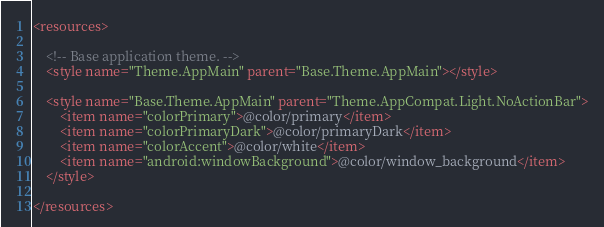Convert code to text. <code><loc_0><loc_0><loc_500><loc_500><_XML_><resources>

    <!-- Base application theme. -->
    <style name="Theme.AppMain" parent="Base.Theme.AppMain"></style>

    <style name="Base.Theme.AppMain" parent="Theme.AppCompat.Light.NoActionBar">
        <item name="colorPrimary">@color/primary</item>
        <item name="colorPrimaryDark">@color/primaryDark</item>
        <item name="colorAccent">@color/white</item>
        <item name="android:windowBackground">@color/window_background</item>
    </style>

</resources>
</code> 